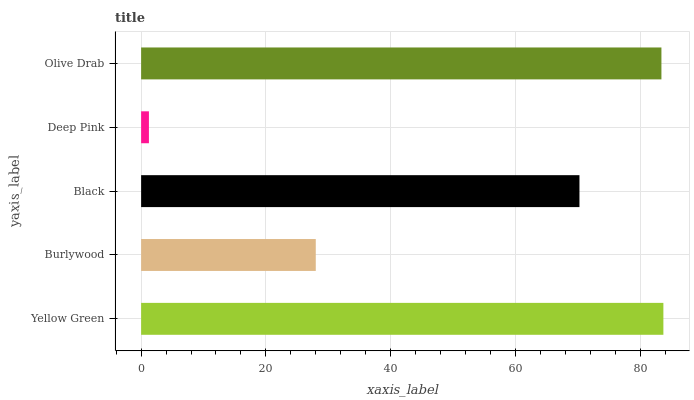Is Deep Pink the minimum?
Answer yes or no. Yes. Is Yellow Green the maximum?
Answer yes or no. Yes. Is Burlywood the minimum?
Answer yes or no. No. Is Burlywood the maximum?
Answer yes or no. No. Is Yellow Green greater than Burlywood?
Answer yes or no. Yes. Is Burlywood less than Yellow Green?
Answer yes or no. Yes. Is Burlywood greater than Yellow Green?
Answer yes or no. No. Is Yellow Green less than Burlywood?
Answer yes or no. No. Is Black the high median?
Answer yes or no. Yes. Is Black the low median?
Answer yes or no. Yes. Is Olive Drab the high median?
Answer yes or no. No. Is Burlywood the low median?
Answer yes or no. No. 